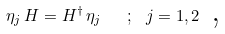<formula> <loc_0><loc_0><loc_500><loc_500>\eta _ { j } \, H = H ^ { \dagger } \, \eta _ { j } \text { \ } \, ; \text { } j = 1 , 2 \text {\ ,\ }</formula> 